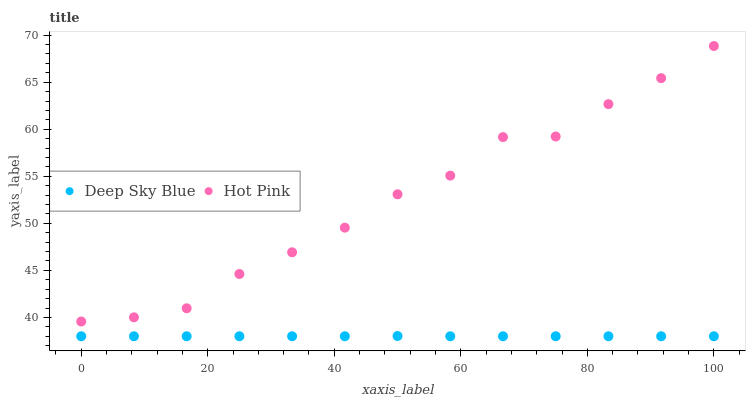Does Deep Sky Blue have the minimum area under the curve?
Answer yes or no. Yes. Does Hot Pink have the maximum area under the curve?
Answer yes or no. Yes. Does Deep Sky Blue have the maximum area under the curve?
Answer yes or no. No. Is Deep Sky Blue the smoothest?
Answer yes or no. Yes. Is Hot Pink the roughest?
Answer yes or no. Yes. Is Deep Sky Blue the roughest?
Answer yes or no. No. Does Deep Sky Blue have the lowest value?
Answer yes or no. Yes. Does Hot Pink have the highest value?
Answer yes or no. Yes. Does Deep Sky Blue have the highest value?
Answer yes or no. No. Is Deep Sky Blue less than Hot Pink?
Answer yes or no. Yes. Is Hot Pink greater than Deep Sky Blue?
Answer yes or no. Yes. Does Deep Sky Blue intersect Hot Pink?
Answer yes or no. No. 